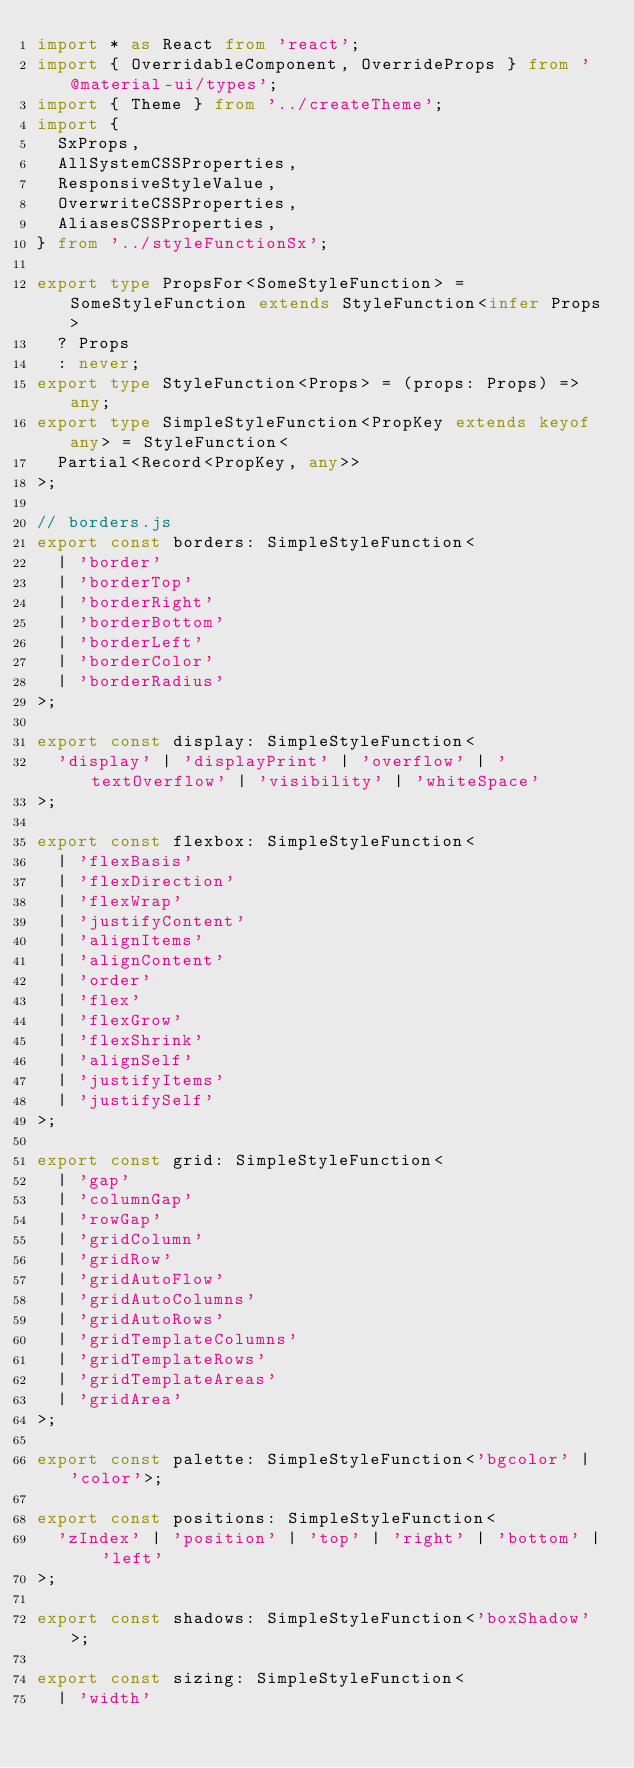<code> <loc_0><loc_0><loc_500><loc_500><_TypeScript_>import * as React from 'react';
import { OverridableComponent, OverrideProps } from '@material-ui/types';
import { Theme } from '../createTheme';
import {
  SxProps,
  AllSystemCSSProperties,
  ResponsiveStyleValue,
  OverwriteCSSProperties,
  AliasesCSSProperties,
} from '../styleFunctionSx';

export type PropsFor<SomeStyleFunction> = SomeStyleFunction extends StyleFunction<infer Props>
  ? Props
  : never;
export type StyleFunction<Props> = (props: Props) => any;
export type SimpleStyleFunction<PropKey extends keyof any> = StyleFunction<
  Partial<Record<PropKey, any>>
>;

// borders.js
export const borders: SimpleStyleFunction<
  | 'border'
  | 'borderTop'
  | 'borderRight'
  | 'borderBottom'
  | 'borderLeft'
  | 'borderColor'
  | 'borderRadius'
>;

export const display: SimpleStyleFunction<
  'display' | 'displayPrint' | 'overflow' | 'textOverflow' | 'visibility' | 'whiteSpace'
>;

export const flexbox: SimpleStyleFunction<
  | 'flexBasis'
  | 'flexDirection'
  | 'flexWrap'
  | 'justifyContent'
  | 'alignItems'
  | 'alignContent'
  | 'order'
  | 'flex'
  | 'flexGrow'
  | 'flexShrink'
  | 'alignSelf'
  | 'justifyItems'
  | 'justifySelf'
>;

export const grid: SimpleStyleFunction<
  | 'gap'
  | 'columnGap'
  | 'rowGap'
  | 'gridColumn'
  | 'gridRow'
  | 'gridAutoFlow'
  | 'gridAutoColumns'
  | 'gridAutoRows'
  | 'gridTemplateColumns'
  | 'gridTemplateRows'
  | 'gridTemplateAreas'
  | 'gridArea'
>;

export const palette: SimpleStyleFunction<'bgcolor' | 'color'>;

export const positions: SimpleStyleFunction<
  'zIndex' | 'position' | 'top' | 'right' | 'bottom' | 'left'
>;

export const shadows: SimpleStyleFunction<'boxShadow'>;

export const sizing: SimpleStyleFunction<
  | 'width'</code> 